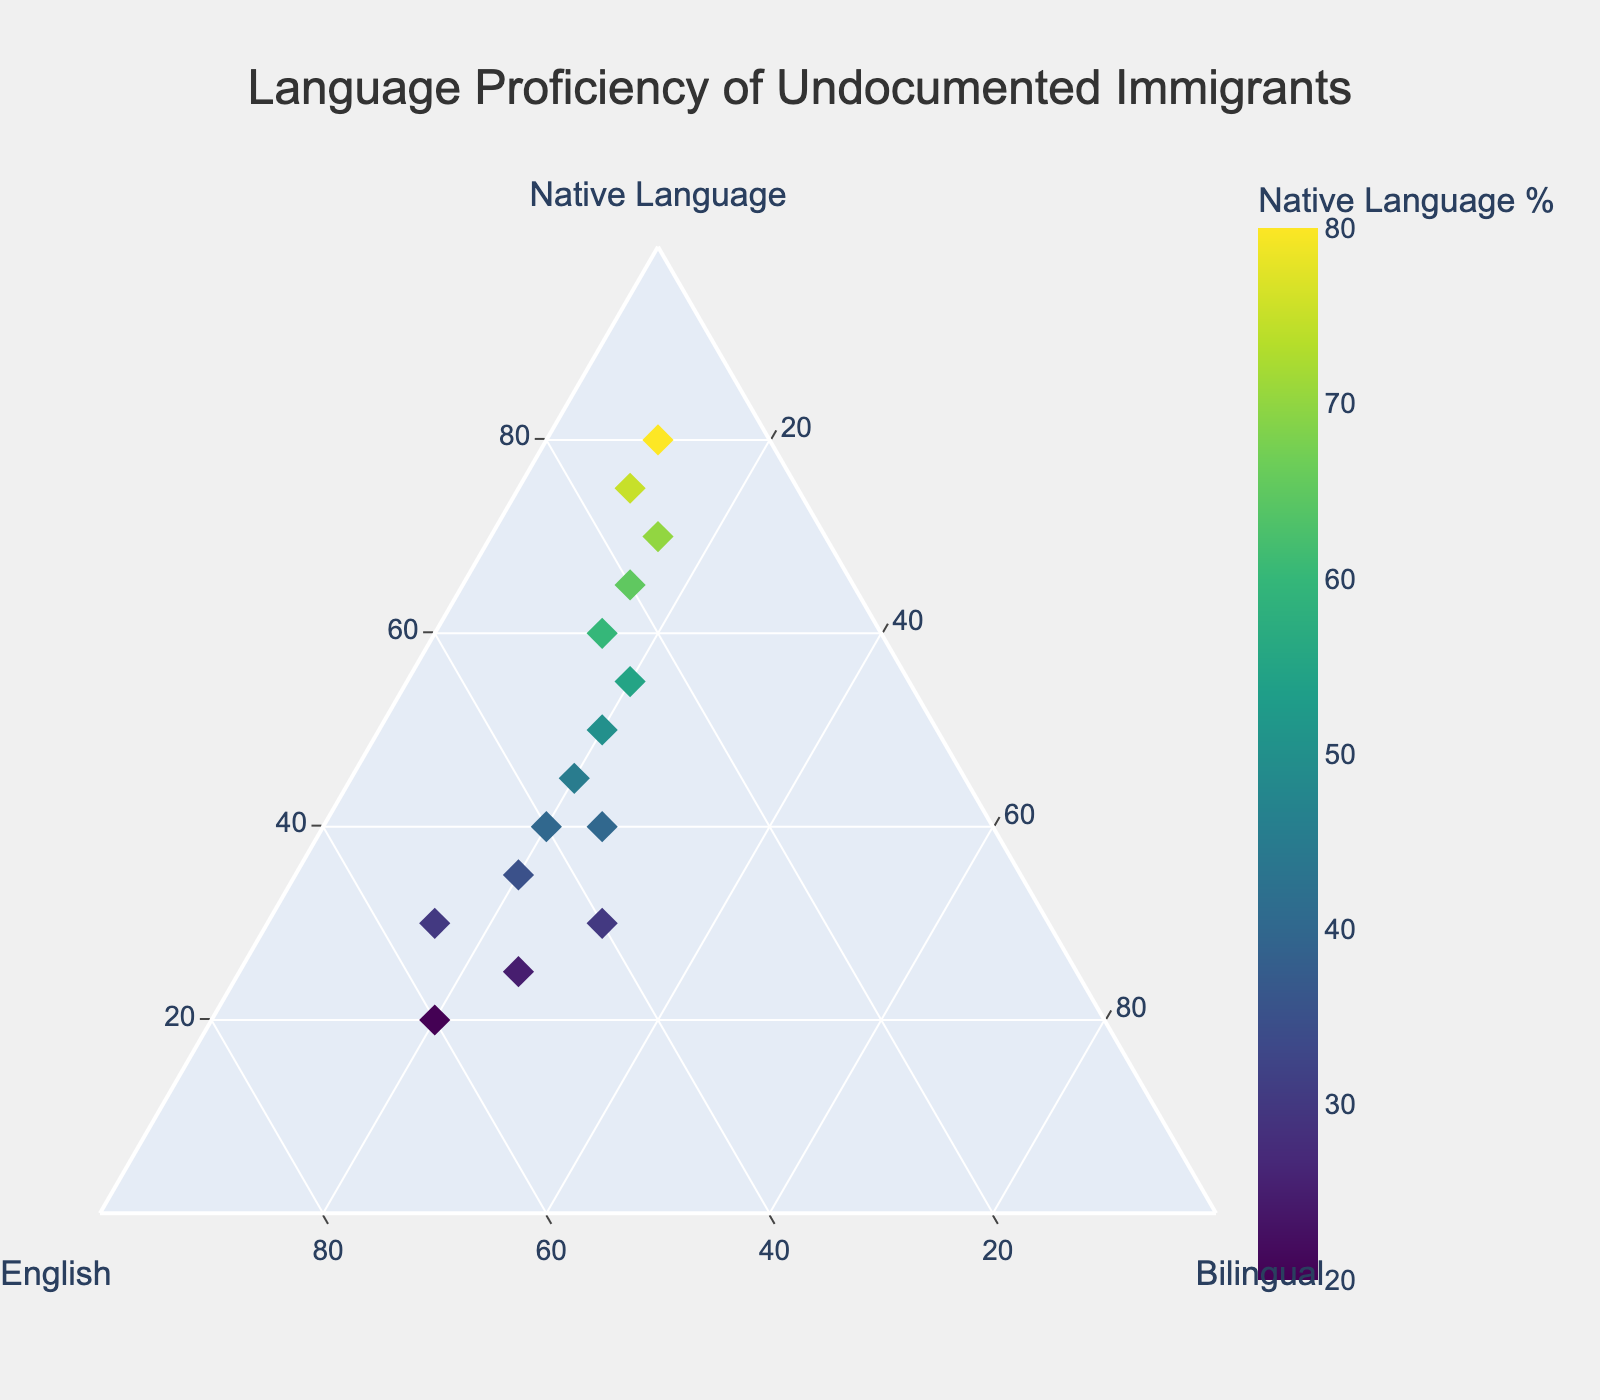What is the title of the figure? The title is displayed at the top center of the figure, just above the ternary plot.
Answer: Language Proficiency of Undocumented Immigrants How many data points are plotted on the ternary plot? Each data point is represented by a diamond marker on the plot. By counting, we can determine the total number of data points.
Answer: 15 What is the dominant language proficiency category for the data point at (65, 20, 15)? This is indicated by the first value in the coordinates, which is the "Native Language" percentage. 65% (Native Language) > 20% (English) > 15% (Bilingual).
Answer: Native Language Which axis title denotes the percentage of those who speak English? The axis title is visually displayed alongside the axis representing English.
Answer: English What is the average percentage of those who are bilingual across all data points? To find the average, sum the percentages for "Bilingual" across all data points and divide by the number of data points. The percentages are: 15, 20, 25, 30, 20, 20, 20, 15, 15, 25, 20, 10, 10, 15, 20. Sum = 280, Average = 280/15.
Answer: 18.67 What is the data point with the lowest percentage for the English category? By observing the "English" axis values, the lowest percentage is 10%. The associated data points are (80, 10, 10) and (75, 15, 10).
Answer: (80, 10, 10) Between data points (40, 40, 20) and (30, 40, 30), which has a higher percentage of bilingual speakers? By comparing the "Bilingual" values, (40, 40, 20) has 20% bilingual, while (30, 40, 30) has 30%.
Answer: (30, 40, 30) Which color scale is used for the markers in the plot? The color scale is visually evident from the color bar on the side of the plot, which is typically labeled or can be discerned from the color gradient.
Answer: Viridis For the data point (30, 55, 15), what is the percentage spoken as a native language? The percentage spoken as a native language is indicated by the first value in the data point tuple.
Answer: 30 What range covers the "Native Language %" color bar? The range is typically stated beside the color bar that indicates the "Native Language %" values. By observing the scale, it starts at the minimum percentage and ends at the maximum percentage found in the data.
Answer: 20% to 80% 